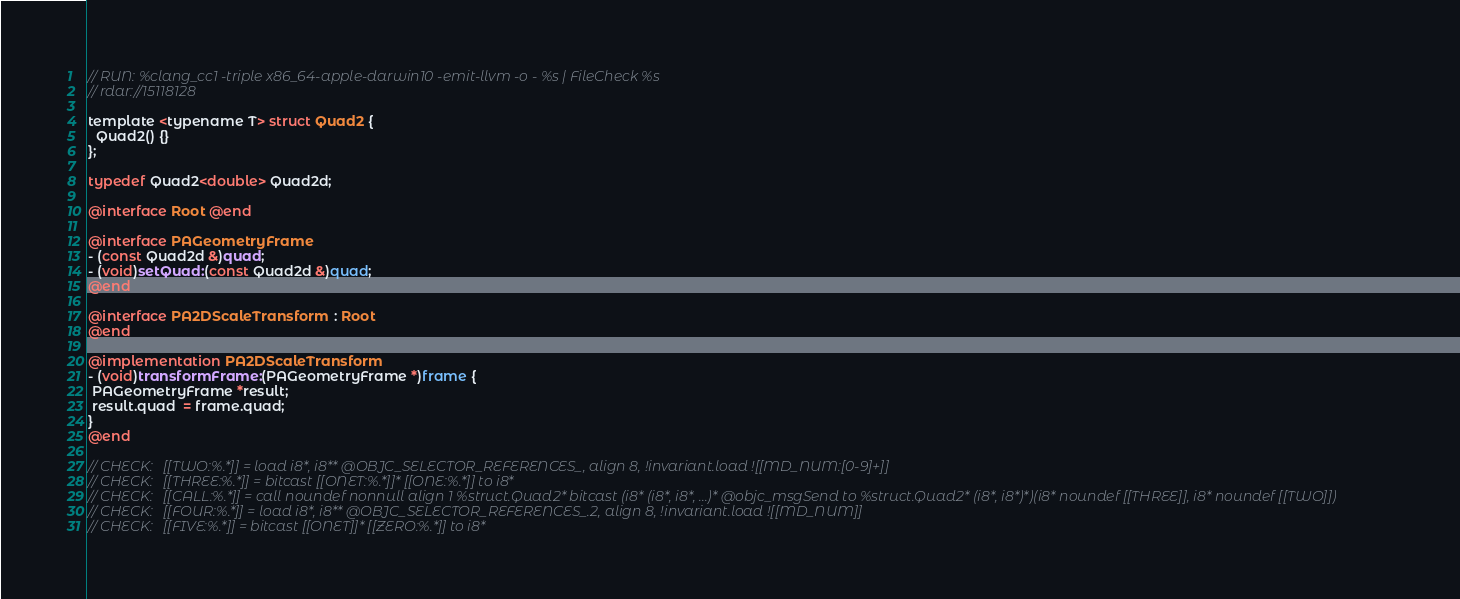Convert code to text. <code><loc_0><loc_0><loc_500><loc_500><_ObjectiveC_>// RUN: %clang_cc1 -triple x86_64-apple-darwin10 -emit-llvm -o - %s | FileCheck %s
// rdar://15118128

template <typename T> struct Quad2 {
  Quad2() {}
};

typedef Quad2<double> Quad2d;

@interface Root @end

@interface PAGeometryFrame
- (const Quad2d &)quad;
- (void)setQuad:(const Quad2d &)quad;
@end

@interface PA2DScaleTransform  : Root
@end

@implementation PA2DScaleTransform
- (void)transformFrame:(PAGeometryFrame *)frame {
 PAGeometryFrame *result;
 result.quad  = frame.quad;
}
@end

// CHECK:   [[TWO:%.*]] = load i8*, i8** @OBJC_SELECTOR_REFERENCES_, align 8, !invariant.load ![[MD_NUM:[0-9]+]]
// CHECK:   [[THREE:%.*]] = bitcast [[ONET:%.*]]* [[ONE:%.*]] to i8*
// CHECK:   [[CALL:%.*]] = call noundef nonnull align 1 %struct.Quad2* bitcast (i8* (i8*, i8*, ...)* @objc_msgSend to %struct.Quad2* (i8*, i8*)*)(i8* noundef [[THREE]], i8* noundef [[TWO]])
// CHECK:   [[FOUR:%.*]] = load i8*, i8** @OBJC_SELECTOR_REFERENCES_.2, align 8, !invariant.load ![[MD_NUM]]
// CHECK:   [[FIVE:%.*]] = bitcast [[ONET]]* [[ZERO:%.*]] to i8*</code> 